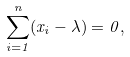Convert formula to latex. <formula><loc_0><loc_0><loc_500><loc_500>\sum _ { i = 1 } ^ { n } ( x _ { i } - \lambda ) = 0 ,</formula> 